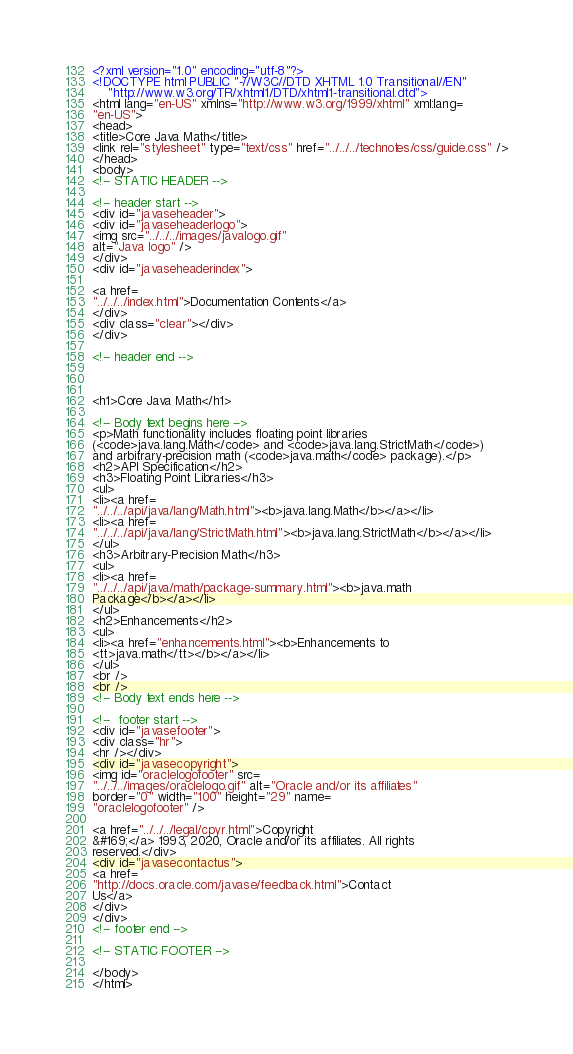Convert code to text. <code><loc_0><loc_0><loc_500><loc_500><_HTML_><?xml version="1.0" encoding="utf-8"?>
<!DOCTYPE html PUBLIC "-//W3C//DTD XHTML 1.0 Transitional//EN"
    "http://www.w3.org/TR/xhtml1/DTD/xhtml1-transitional.dtd">
<html lang="en-US" xmlns="http://www.w3.org/1999/xhtml" xml:lang=
"en-US">
<head>
<title>Core Java Math</title>
<link rel="stylesheet" type="text/css" href="../../../technotes/css/guide.css" />
</head>
<body>
<!-- STATIC HEADER -->

<!-- header start -->
<div id="javaseheader">
<div id="javaseheaderlogo">
<img src="../../../images/javalogo.gif"
alt="Java logo" />
</div>
<div id="javaseheaderindex">

<a href=
"../../../index.html">Documentation Contents</a>
</div>
<div class="clear"></div>
</div>

<!-- header end -->



<h1>Core Java Math</h1>

<!-- Body text begins here -->
<p>Math functionality includes floating point libraries
(<code>java.lang.Math</code> and <code>java.lang.StrictMath</code>)
and arbitrary-precision math (<code>java.math</code> package).</p>
<h2>API Specification</h2>
<h3>Floating Point Libraries</h3>
<ul>
<li><a href=
"../../../api/java/lang/Math.html"><b>java.lang.Math</b></a></li>
<li><a href=
"../../../api/java/lang/StrictMath.html"><b>java.lang.StrictMath</b></a></li>
</ul>
<h3>Arbitrary-Precision Math</h3>
<ul>
<li><a href=
"../../../api/java/math/package-summary.html"><b>java.math
Package</b></a></li>
</ul>
<h2>Enhancements</h2>
<ul>
<li><a href="enhancements.html"><b>Enhancements to
<tt>java.math</tt></b></a></li>
</ul>
<br />
<br />
<!-- Body text ends here -->

<!--  footer start -->
<div id="javasefooter">
<div class="hr">
<hr /></div>
<div id="javasecopyright">
<img id="oraclelogofooter" src=
"../../../images/oraclelogo.gif" alt="Oracle and/or its affiliates"
border="0" width="100" height="29" name=
"oraclelogofooter" />

<a href="../../../legal/cpyr.html">Copyright
&#169;</a> 1993, 2020, Oracle and/or its affiliates. All rights
reserved.</div>
<div id="javasecontactus">
<a href=
"http://docs.oracle.com/javase/feedback.html">Contact
Us</a>
</div>
</div>
<!-- footer end -->

<!-- STATIC FOOTER -->

</body>
</html>
</code> 